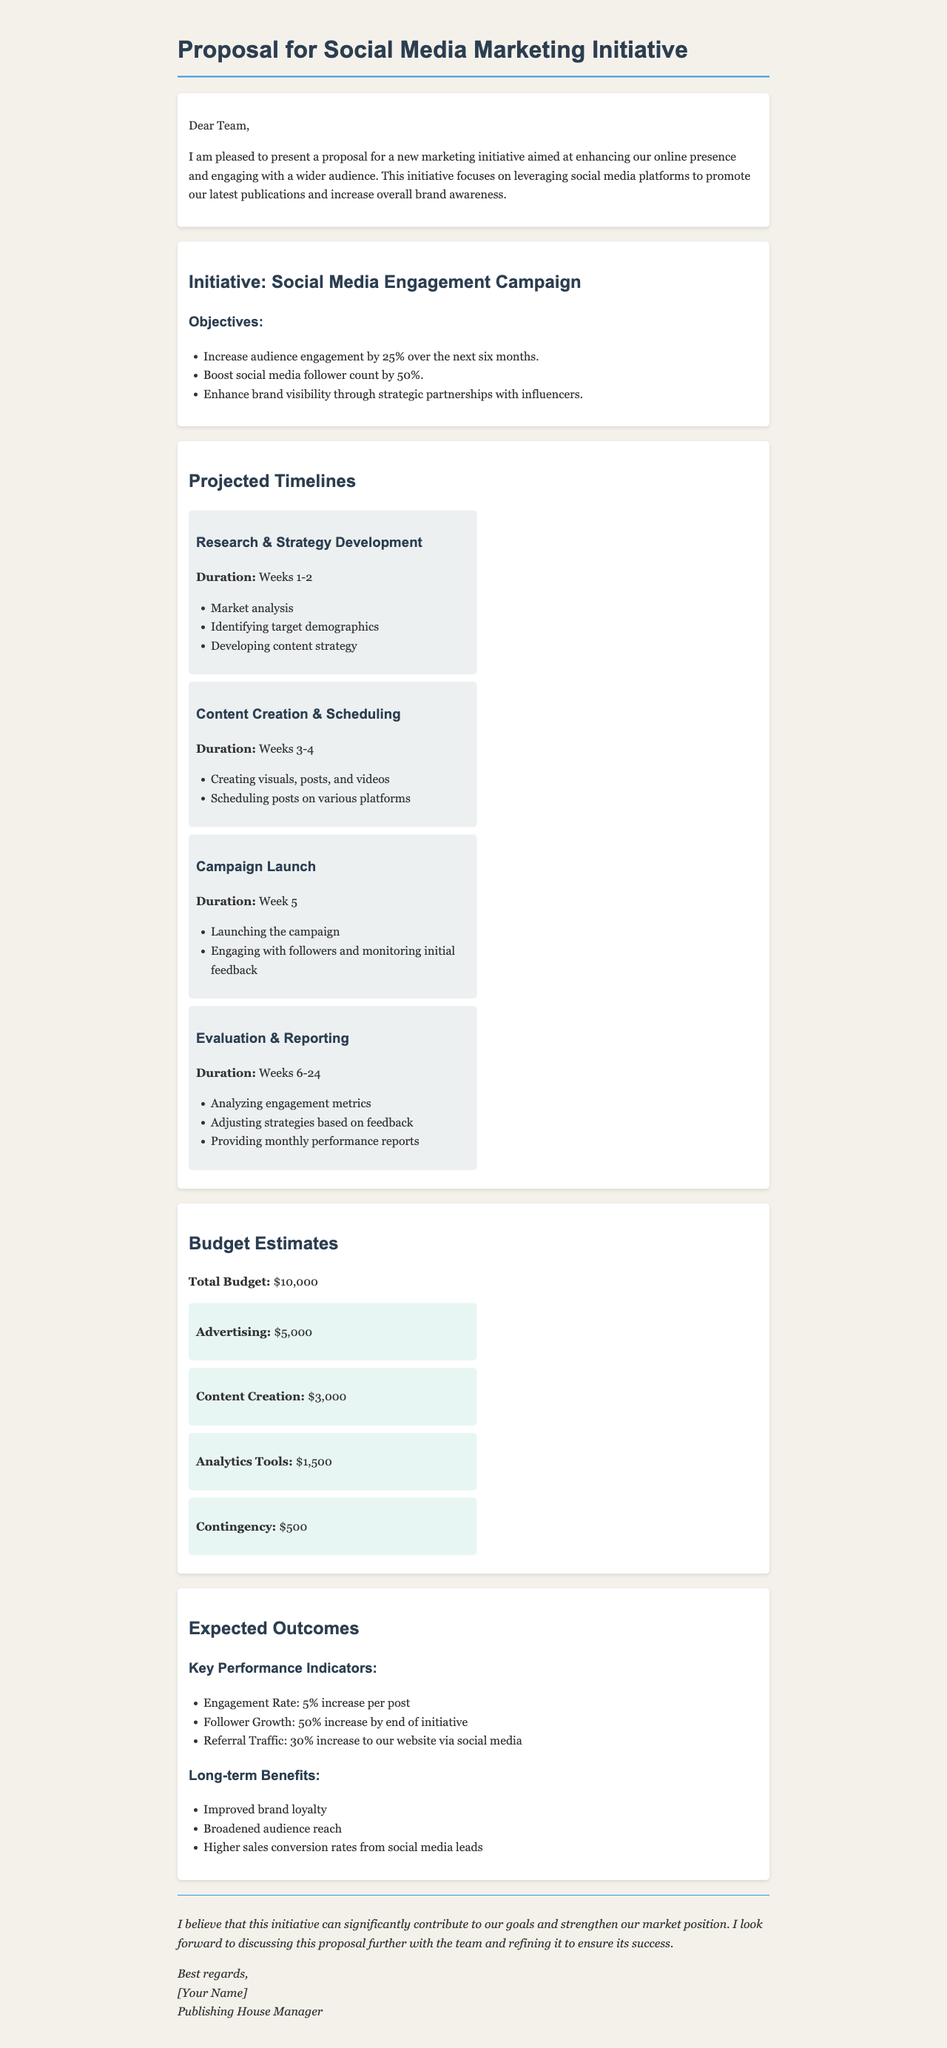What is the total budget for the initiative? The total budget is explicitly stated in the document under the budget estimates section.
Answer: $10,000 What percentage increase in audience engagement is targeted? The objective mentions a specific percentage related to audience engagement found in the objectives section.
Answer: 25% What is the duration of the research and strategy development phase? The timeline section provides the specific weeks attributed to this phase.
Answer: Weeks 1-2 What is one key expected outcome of the initiative? The expected outcomes section lists various key performance indicators and long-term benefits.
Answer: Improved brand loyalty How much is allocated for content creation? The budget breakdown specifies this amount under content creation.
Answer: $3,000 What is the follower growth target by the end of the initiative? The document indicates a specific percentage for follower growth in the 'Expected Outcomes' section.
Answer: 50% When is the campaign launch scheduled? The timeline clearly states when the campaign launch is planned to happen.
Answer: Week 5 Which tools are budgeted for analytics? The budget breakdown lists this specific expense under analytics tools.
Answer: $1,500 What is the main initiative presented in the proposal? The title and introduction of the document clearly state the focus of the marketing initiative.
Answer: Social Media Engagement Campaign 